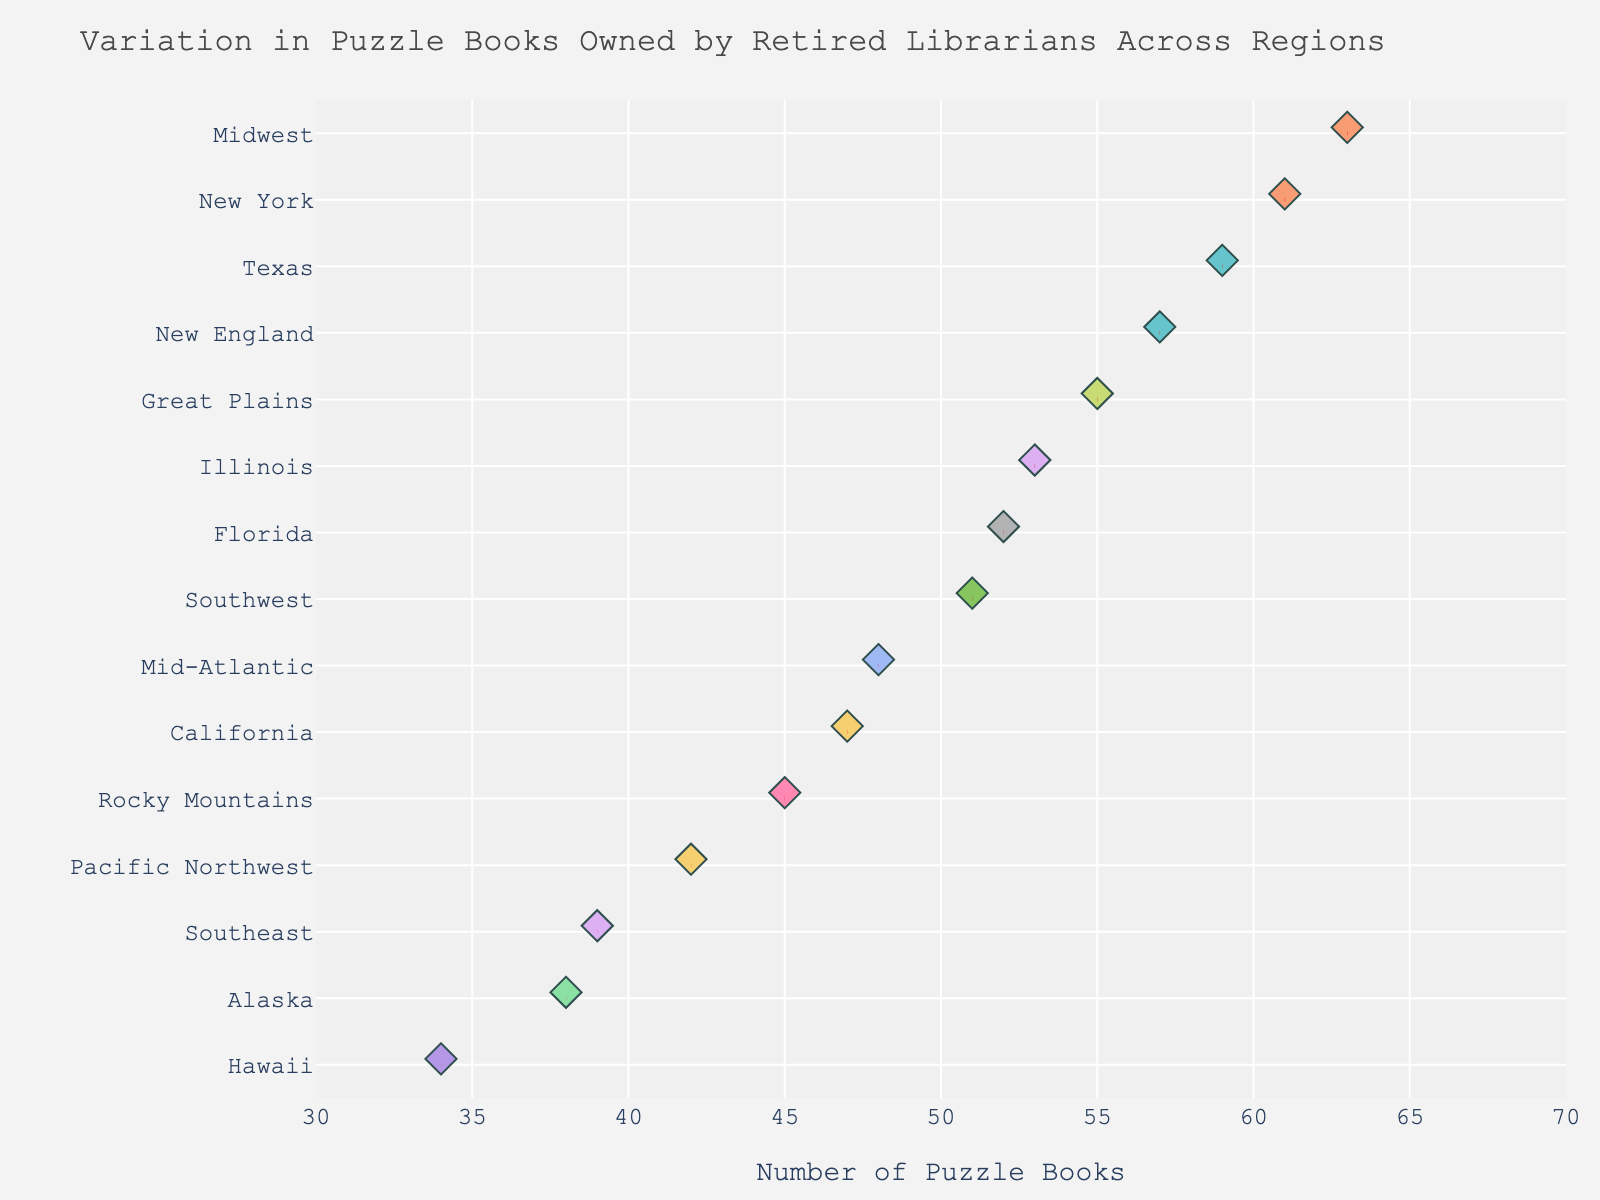Which region has the highest number of puzzle books owned by retired librarians? The figure shows a strip plot with the number of puzzle books on the x-axis and regions on the y-axis. The region with the highest number of puzzle books is recognized by the point furthest to the right.
Answer: Midwest What is the title of the plot? The title is displayed at the top center of the figure and summarizes what the plot is about.
Answer: Variation in Puzzle Books Owned by Retired Librarians Across Regions Which region has the lowest number of puzzle books owned and what is the number? From the plot, identify the point furthest to the left and note its corresponding region and value.
Answer: Hawaii, 34 How many puzzle books do retired librarians in Texas own? Locate the 'Texas' category on the y-axis and trace the data point horizontally to read the number on the x-axis.
Answer: 59 What is the range of the x-axis (number of puzzle books)? The range can be identified by looking at the minimum and maximum values labeled on the x-axis.
Answer: 30 to 70 Which regions have more than 50 puzzle books owned? Find the data points on the right side of the 50 mark on the x-axis and note their corresponding regions.
Answer: Midwest, Texas, New England, Great Plains, Illinois, Florida, New York What average line indicates the mean number of puzzle books owned in the Midwest region? Locate the line at the center of the data points for the Midwest, marked in red and dashed, indicating the mean.
Answer: 63 Compare the number of puzzle books owned by librarians in California and Florida. Which state has more, and by how much? Locate the data points corresponding to California and Florida and note their values, then calculate the difference. Florida (52) - California (47) = 5
Answer: Florida, by 5 books Is there any region with exactly 45 puzzle books? Observe the plot to see if a data point aligns precisely with the 45 mark on the x-axis and identify its region.
Answer: Rocky Mountains What's the median number of puzzle books owned by librarians across all regions? Arrange the number of puzzle books in ascending order and find the middle value. Ordered values: 34, 38, 39, 42, 45, 47, 48, 51, 52, 53, 55, 57, 59, 61, 63. The median is the 8th value.
Answer: 51 